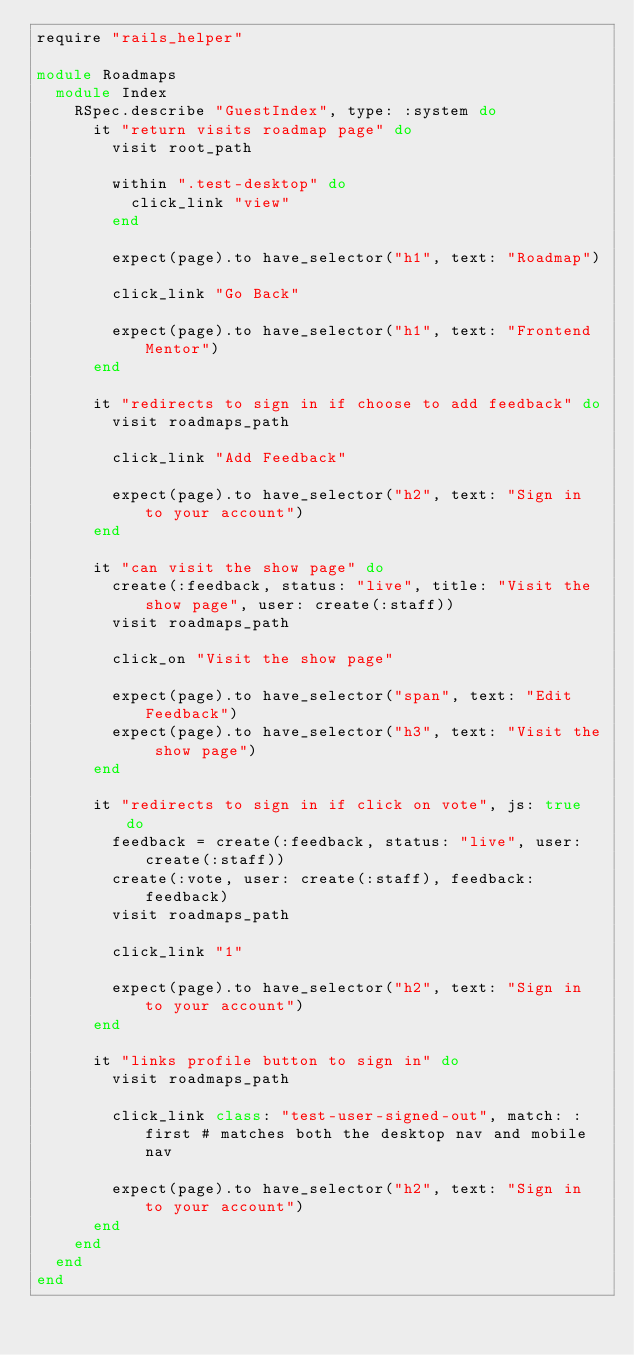<code> <loc_0><loc_0><loc_500><loc_500><_Ruby_>require "rails_helper"

module Roadmaps
  module Index
    RSpec.describe "GuestIndex", type: :system do
      it "return visits roadmap page" do
        visit root_path

        within ".test-desktop" do
          click_link "view"
        end

        expect(page).to have_selector("h1", text: "Roadmap")

        click_link "Go Back"

        expect(page).to have_selector("h1", text: "Frontend Mentor")
      end

      it "redirects to sign in if choose to add feedback" do
        visit roadmaps_path

        click_link "Add Feedback"

        expect(page).to have_selector("h2", text: "Sign in to your account")
      end

      it "can visit the show page" do
        create(:feedback, status: "live", title: "Visit the show page", user: create(:staff))
        visit roadmaps_path

        click_on "Visit the show page"

        expect(page).to have_selector("span", text: "Edit Feedback")
        expect(page).to have_selector("h3", text: "Visit the show page")
      end

      it "redirects to sign in if click on vote", js: true do
        feedback = create(:feedback, status: "live", user: create(:staff))
        create(:vote, user: create(:staff), feedback: feedback)
        visit roadmaps_path

        click_link "1"

        expect(page).to have_selector("h2", text: "Sign in to your account")
      end

      it "links profile button to sign in" do
        visit roadmaps_path

        click_link class: "test-user-signed-out", match: :first # matches both the desktop nav and mobile nav

        expect(page).to have_selector("h2", text: "Sign in to your account")
      end
    end
  end
end
</code> 